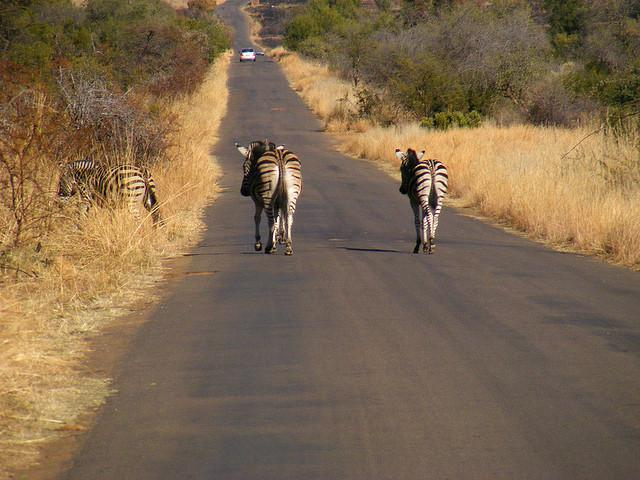What are the animals showing to the camera? Please explain your reasoning. backside. The zebras are facing away from the camera. 